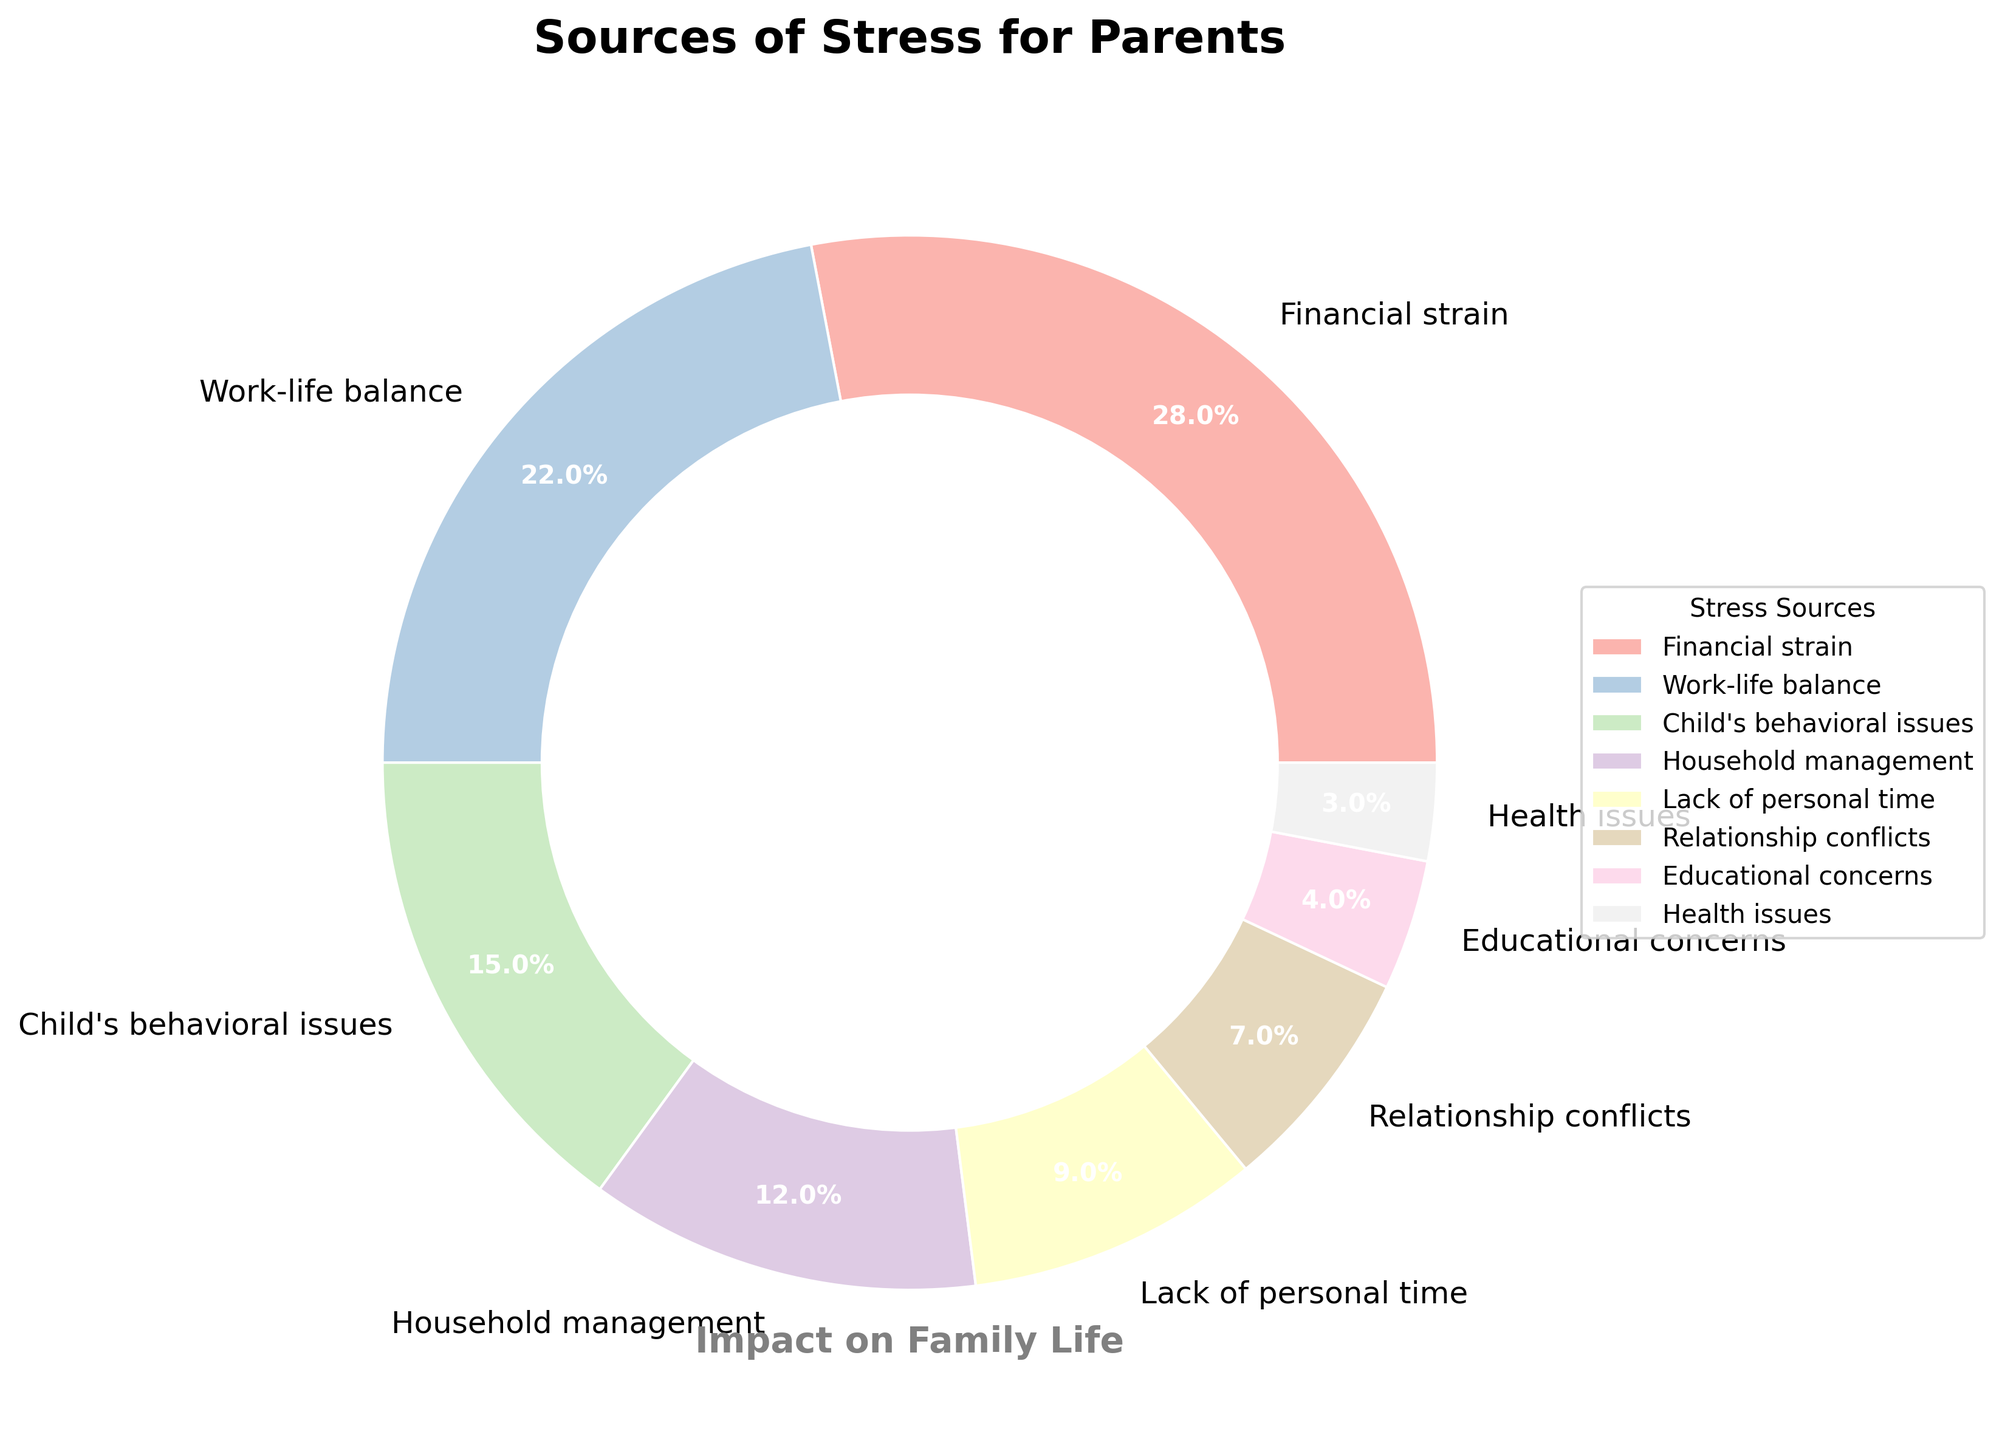What is the source of stress with the highest impact percentage? The chart shows various slices, each labeled with the source of stress and its impact percentage. The largest slice corresponds to Financial strain, which has the highest impact percentage.
Answer: Financial strain Which source of stress has a greater impact, Work-life balance or Child's behavioral issues? By comparing the sizes of the slices labeled Work-life balance and Child's behavioral issues, Work-life balance has a larger slice with 22% compared to Child's behavioral issues at 15%.
Answer: Work-life balance What is the combined impact percentage of Relationship conflicts and Educational concerns? The slices for Relationship conflicts and Educational concerns show 7% and 4% respectively. Adding these percentages gives 7 + 4 = 11%.
Answer: 11% Which sources of stress have an impact percentage less than 10%? By examining the slices, Lack of personal time (9%), Relationship conflicts (7%), Educational concerns (4%), and Health issues (3%) are all less than 10%.
Answer: Lack of personal time, Relationship conflicts, Educational concerns, Health issues By how much does Financial strain's impact percentage exceed Household management's impact percentage? Financial strain has a 28% impact, and Household management has a 12% impact. The difference is 28 - 12 = 16%.
Answer: 16% What percentage of the impact is due to sources of stress related to time management (Work-life balance and Lack of personal time)? Work-life balance has a 22% impact and Lack of personal time has 9%. Adding these gives 22 + 9 = 31%.
Answer: 31% Rank the sources of stress from highest to lowest impact on family life. Reviewing the percentages, the ranking is Financial strain (28%), Work-life balance (22%), Child's behavioral issues (15%), Household management (12%), Lack of personal time (9%), Relationship conflicts (7%), Educational concerns (4%), and Health issues (3%).
Answer: Financial strain, Work-life balance, Child's behavioral issues, Household management, Lack of personal time, Relationship conflicts, Educational concerns, Health issues 